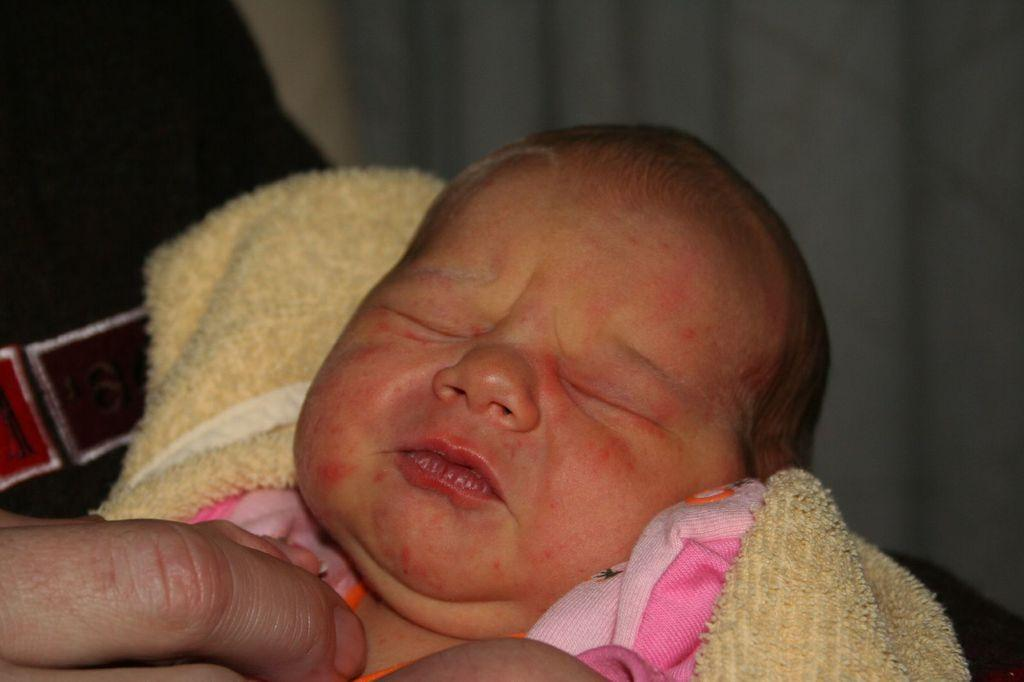What is the main subject of the image? There is a baby in the image. How is the baby dressed or covered in the image? The baby is wrapped in a cloth. What can be seen on the left side of the image? There is a person's hand on the left side of the image. Can you describe the background of the image? The background of the image is blurred. What type of farming equipment can be seen in the image? There is no farming equipment present in the image; it features a baby wrapped in a cloth with a person's hand on the left side. How does the baby connect to the window in the image? There is no window present in the image, and the baby is not connected to any window. 